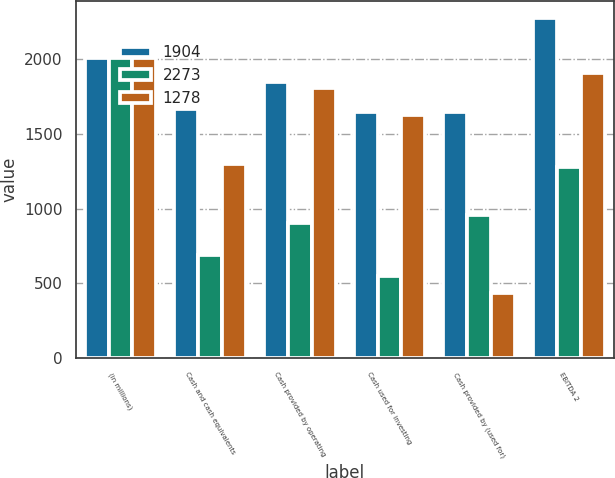<chart> <loc_0><loc_0><loc_500><loc_500><stacked_bar_chart><ecel><fcel>(in millions)<fcel>Cash and cash equivalents<fcel>Cash provided by operating<fcel>Cash used for investing<fcel>Cash provided by (used for)<fcel>EBITDA 2<nl><fcel>1904<fcel>2006<fcel>1668<fcel>1845<fcel>1645<fcel>1645<fcel>2273<nl><fcel>2273<fcel>2005<fcel>689<fcel>903<fcel>551<fcel>954<fcel>1278<nl><fcel>1278<fcel>2004<fcel>1296<fcel>1804<fcel>1622<fcel>439<fcel>1904<nl></chart> 